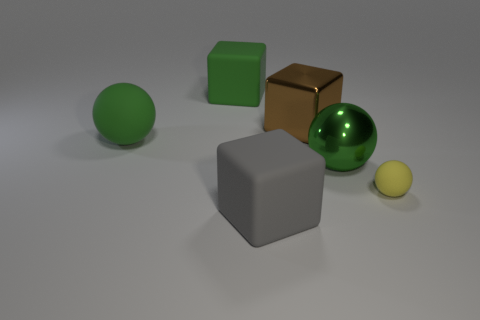Subtract all gray cubes. How many green spheres are left? 2 Subtract all matte blocks. How many blocks are left? 1 Add 2 brown cubes. How many objects exist? 8 Subtract 1 blocks. How many blocks are left? 2 Add 6 big green matte balls. How many big green matte balls are left? 7 Add 2 small cyan matte cylinders. How many small cyan matte cylinders exist? 2 Subtract 0 brown spheres. How many objects are left? 6 Subtract all big matte cubes. Subtract all brown blocks. How many objects are left? 3 